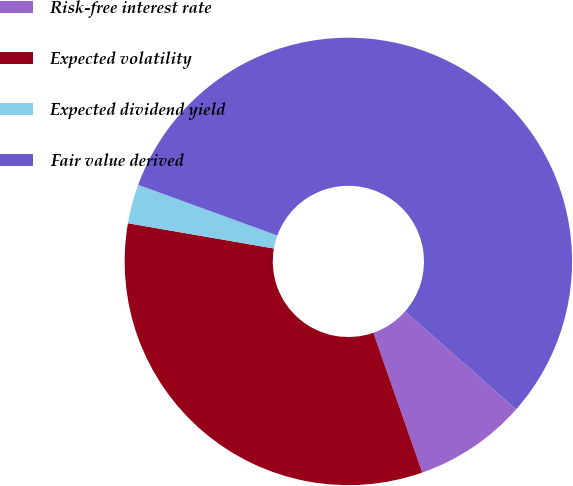Convert chart to OTSL. <chart><loc_0><loc_0><loc_500><loc_500><pie_chart><fcel>Risk-free interest rate<fcel>Expected volatility<fcel>Expected dividend yield<fcel>Fair value derived<nl><fcel>8.14%<fcel>33.09%<fcel>2.83%<fcel>55.94%<nl></chart> 